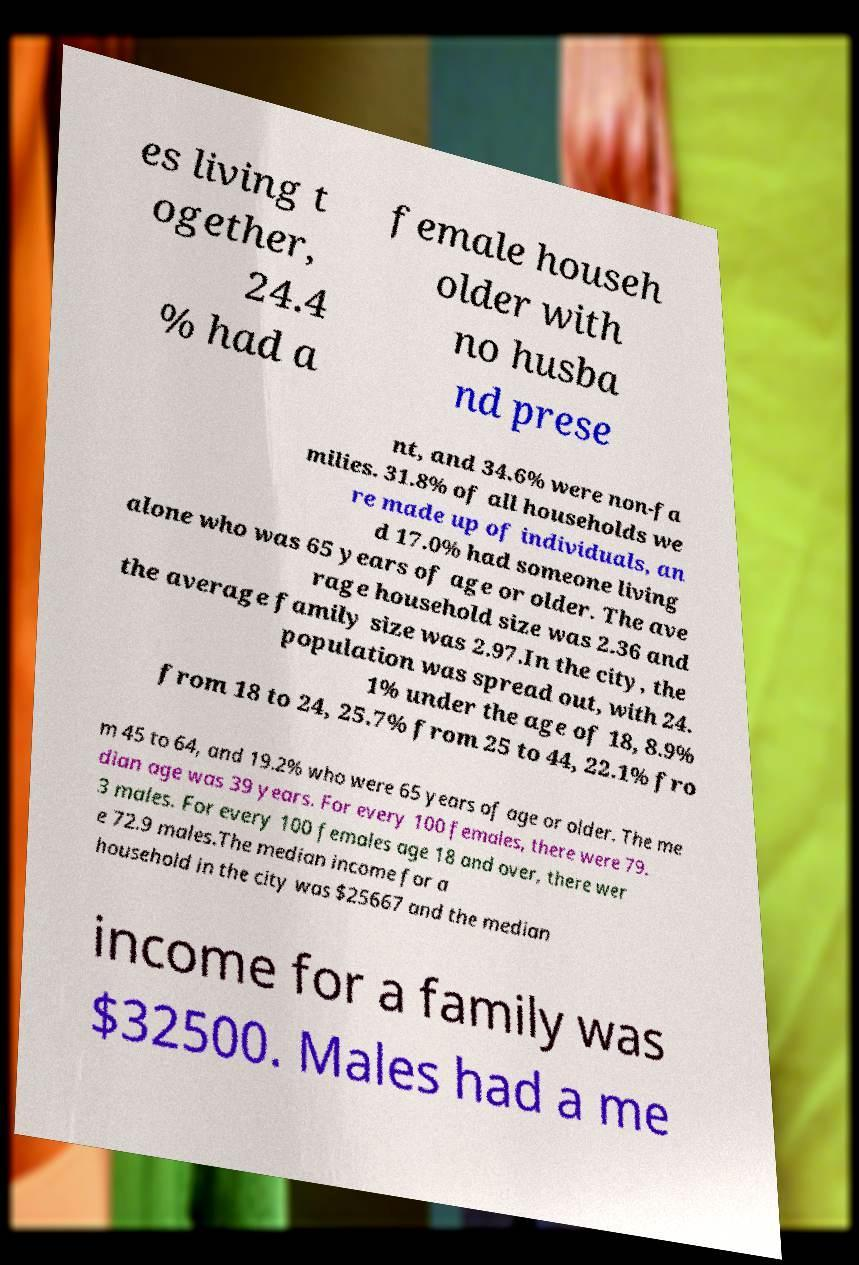There's text embedded in this image that I need extracted. Can you transcribe it verbatim? es living t ogether, 24.4 % had a female househ older with no husba nd prese nt, and 34.6% were non-fa milies. 31.8% of all households we re made up of individuals, an d 17.0% had someone living alone who was 65 years of age or older. The ave rage household size was 2.36 and the average family size was 2.97.In the city, the population was spread out, with 24. 1% under the age of 18, 8.9% from 18 to 24, 25.7% from 25 to 44, 22.1% fro m 45 to 64, and 19.2% who were 65 years of age or older. The me dian age was 39 years. For every 100 females, there were 79. 3 males. For every 100 females age 18 and over, there wer e 72.9 males.The median income for a household in the city was $25667 and the median income for a family was $32500. Males had a me 